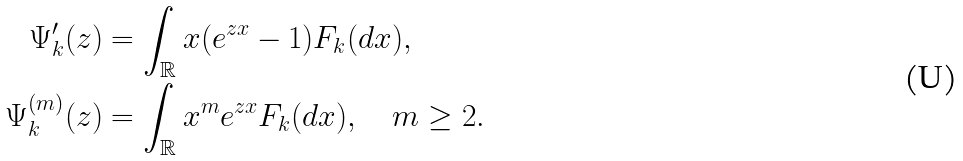<formula> <loc_0><loc_0><loc_500><loc_500>\Psi _ { k } ^ { \prime } ( z ) & = \int _ { \mathbb { R } } x ( e ^ { z x } - 1 ) F _ { k } ( d x ) , \\ \Psi _ { k } ^ { ( m ) } ( z ) & = \int _ { \mathbb { R } } x ^ { m } e ^ { z x } F _ { k } ( d x ) , \quad m \geq 2 .</formula> 